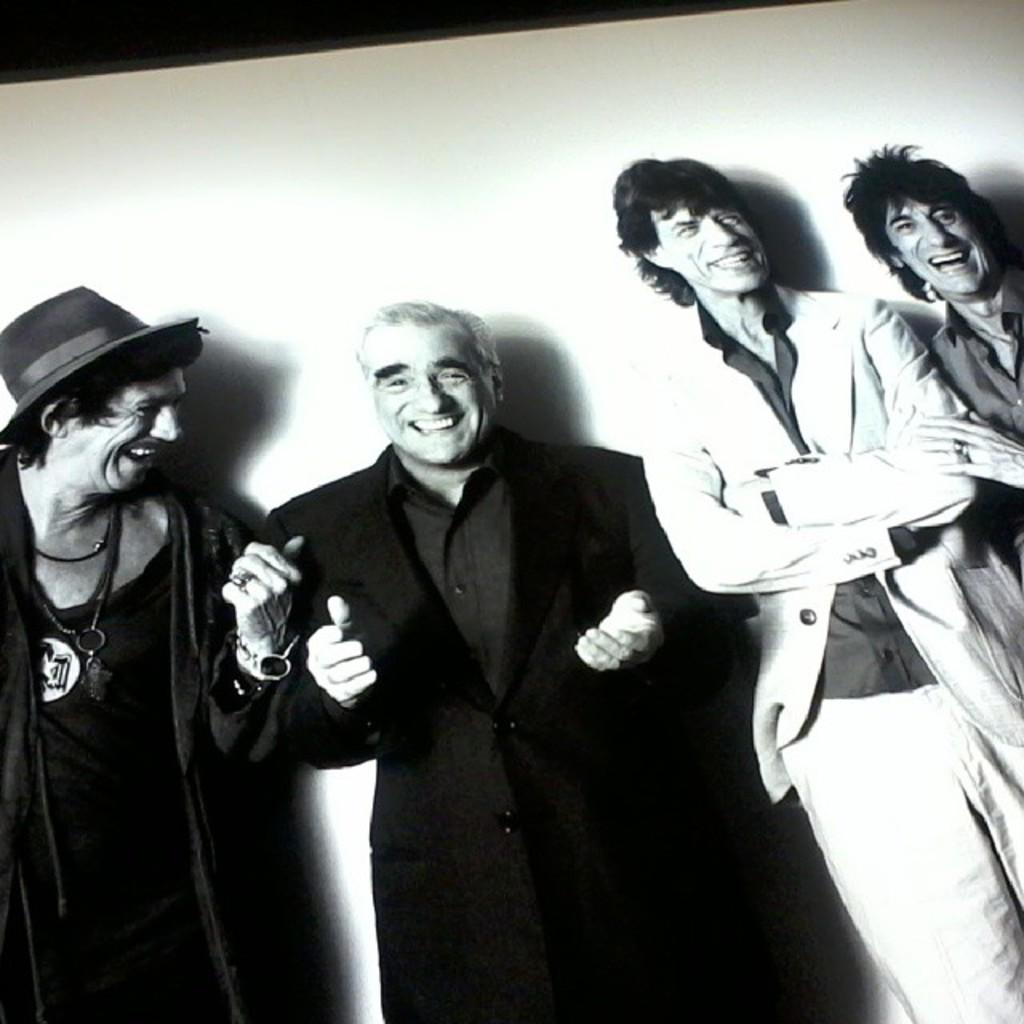How many people are present in the image? There are four people in the image. What expressions do the people have on their faces? The people are wearing smiles on their faces. What can be seen in the background of the image? There is a wall visible in the background of the image. How many rabbits can be seen playing with the pig and bear in the image? There are no rabbits, pigs, or bears present in the image; it features four people with smiles on their faces. 